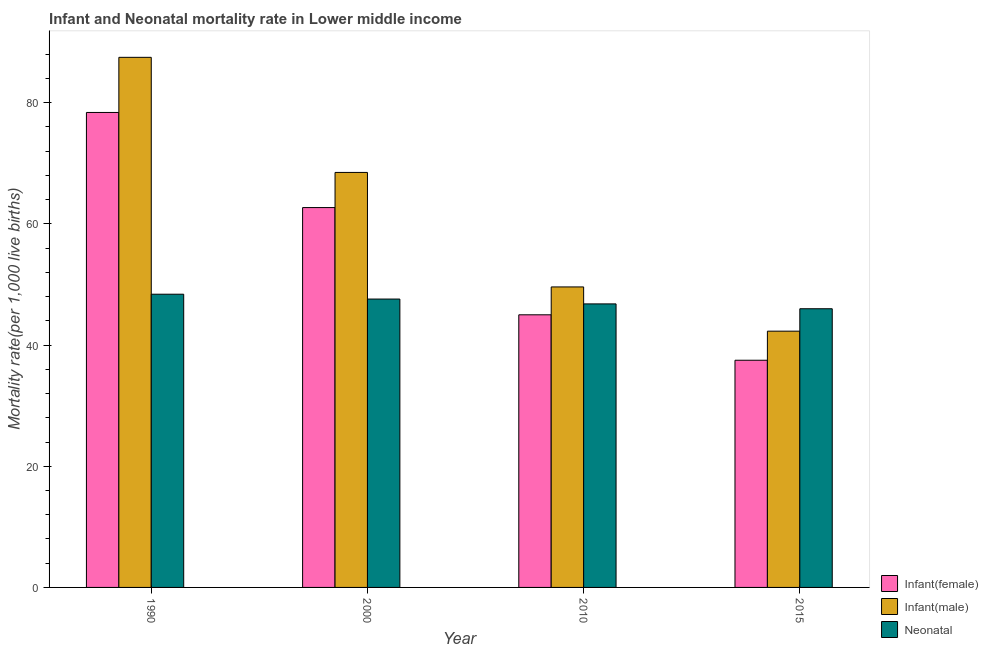How many groups of bars are there?
Offer a very short reply. 4. Are the number of bars on each tick of the X-axis equal?
Your answer should be very brief. Yes. How many bars are there on the 4th tick from the left?
Provide a succinct answer. 3. How many bars are there on the 4th tick from the right?
Make the answer very short. 3. In how many cases, is the number of bars for a given year not equal to the number of legend labels?
Provide a short and direct response. 0. What is the infant mortality rate(female) in 2000?
Provide a short and direct response. 62.7. Across all years, what is the maximum infant mortality rate(female)?
Offer a very short reply. 78.4. Across all years, what is the minimum infant mortality rate(male)?
Ensure brevity in your answer.  42.3. In which year was the neonatal mortality rate maximum?
Offer a very short reply. 1990. In which year was the infant mortality rate(female) minimum?
Your response must be concise. 2015. What is the total neonatal mortality rate in the graph?
Keep it short and to the point. 188.8. What is the difference between the neonatal mortality rate in 1990 and that in 2000?
Give a very brief answer. 0.8. What is the difference between the neonatal mortality rate in 2015 and the infant mortality rate(female) in 1990?
Your answer should be compact. -2.4. What is the average infant mortality rate(female) per year?
Offer a terse response. 55.9. In the year 1990, what is the difference between the neonatal mortality rate and infant mortality rate(male)?
Make the answer very short. 0. What is the ratio of the neonatal mortality rate in 1990 to that in 2000?
Provide a succinct answer. 1.02. Is the infant mortality rate(female) in 2000 less than that in 2010?
Your answer should be compact. No. What is the difference between the highest and the second highest infant mortality rate(female)?
Offer a very short reply. 15.7. What is the difference between the highest and the lowest neonatal mortality rate?
Your response must be concise. 2.4. Is the sum of the neonatal mortality rate in 1990 and 2015 greater than the maximum infant mortality rate(female) across all years?
Provide a succinct answer. Yes. What does the 3rd bar from the left in 2000 represents?
Offer a terse response. Neonatal . What does the 2nd bar from the right in 1990 represents?
Your answer should be compact. Infant(male). Is it the case that in every year, the sum of the infant mortality rate(female) and infant mortality rate(male) is greater than the neonatal mortality rate?
Ensure brevity in your answer.  Yes. How many years are there in the graph?
Provide a succinct answer. 4. Are the values on the major ticks of Y-axis written in scientific E-notation?
Ensure brevity in your answer.  No. Where does the legend appear in the graph?
Make the answer very short. Bottom right. How many legend labels are there?
Offer a terse response. 3. What is the title of the graph?
Provide a short and direct response. Infant and Neonatal mortality rate in Lower middle income. Does "Oil sources" appear as one of the legend labels in the graph?
Provide a short and direct response. No. What is the label or title of the X-axis?
Offer a very short reply. Year. What is the label or title of the Y-axis?
Your answer should be compact. Mortality rate(per 1,0 live births). What is the Mortality rate(per 1,000 live births) in Infant(female) in 1990?
Your answer should be very brief. 78.4. What is the Mortality rate(per 1,000 live births) in Infant(male) in 1990?
Ensure brevity in your answer.  87.5. What is the Mortality rate(per 1,000 live births) in Neonatal  in 1990?
Keep it short and to the point. 48.4. What is the Mortality rate(per 1,000 live births) of Infant(female) in 2000?
Your answer should be very brief. 62.7. What is the Mortality rate(per 1,000 live births) of Infant(male) in 2000?
Offer a terse response. 68.5. What is the Mortality rate(per 1,000 live births) in Neonatal  in 2000?
Provide a succinct answer. 47.6. What is the Mortality rate(per 1,000 live births) of Infant(male) in 2010?
Your answer should be compact. 49.6. What is the Mortality rate(per 1,000 live births) of Neonatal  in 2010?
Your answer should be compact. 46.8. What is the Mortality rate(per 1,000 live births) in Infant(female) in 2015?
Ensure brevity in your answer.  37.5. What is the Mortality rate(per 1,000 live births) in Infant(male) in 2015?
Offer a very short reply. 42.3. Across all years, what is the maximum Mortality rate(per 1,000 live births) in Infant(female)?
Keep it short and to the point. 78.4. Across all years, what is the maximum Mortality rate(per 1,000 live births) in Infant(male)?
Keep it short and to the point. 87.5. Across all years, what is the maximum Mortality rate(per 1,000 live births) in Neonatal ?
Offer a very short reply. 48.4. Across all years, what is the minimum Mortality rate(per 1,000 live births) of Infant(female)?
Ensure brevity in your answer.  37.5. Across all years, what is the minimum Mortality rate(per 1,000 live births) of Infant(male)?
Provide a succinct answer. 42.3. What is the total Mortality rate(per 1,000 live births) in Infant(female) in the graph?
Offer a terse response. 223.6. What is the total Mortality rate(per 1,000 live births) of Infant(male) in the graph?
Make the answer very short. 247.9. What is the total Mortality rate(per 1,000 live births) of Neonatal  in the graph?
Provide a succinct answer. 188.8. What is the difference between the Mortality rate(per 1,000 live births) in Infant(female) in 1990 and that in 2000?
Make the answer very short. 15.7. What is the difference between the Mortality rate(per 1,000 live births) in Infant(female) in 1990 and that in 2010?
Make the answer very short. 33.4. What is the difference between the Mortality rate(per 1,000 live births) in Infant(male) in 1990 and that in 2010?
Provide a succinct answer. 37.9. What is the difference between the Mortality rate(per 1,000 live births) in Neonatal  in 1990 and that in 2010?
Ensure brevity in your answer.  1.6. What is the difference between the Mortality rate(per 1,000 live births) in Infant(female) in 1990 and that in 2015?
Your answer should be compact. 40.9. What is the difference between the Mortality rate(per 1,000 live births) of Infant(male) in 1990 and that in 2015?
Make the answer very short. 45.2. What is the difference between the Mortality rate(per 1,000 live births) of Infant(female) in 2000 and that in 2010?
Provide a succinct answer. 17.7. What is the difference between the Mortality rate(per 1,000 live births) of Infant(male) in 2000 and that in 2010?
Ensure brevity in your answer.  18.9. What is the difference between the Mortality rate(per 1,000 live births) in Infant(female) in 2000 and that in 2015?
Ensure brevity in your answer.  25.2. What is the difference between the Mortality rate(per 1,000 live births) of Infant(male) in 2000 and that in 2015?
Your response must be concise. 26.2. What is the difference between the Mortality rate(per 1,000 live births) in Infant(female) in 2010 and that in 2015?
Ensure brevity in your answer.  7.5. What is the difference between the Mortality rate(per 1,000 live births) in Infant(female) in 1990 and the Mortality rate(per 1,000 live births) in Infant(male) in 2000?
Offer a very short reply. 9.9. What is the difference between the Mortality rate(per 1,000 live births) in Infant(female) in 1990 and the Mortality rate(per 1,000 live births) in Neonatal  in 2000?
Provide a short and direct response. 30.8. What is the difference between the Mortality rate(per 1,000 live births) in Infant(male) in 1990 and the Mortality rate(per 1,000 live births) in Neonatal  in 2000?
Your response must be concise. 39.9. What is the difference between the Mortality rate(per 1,000 live births) of Infant(female) in 1990 and the Mortality rate(per 1,000 live births) of Infant(male) in 2010?
Give a very brief answer. 28.8. What is the difference between the Mortality rate(per 1,000 live births) of Infant(female) in 1990 and the Mortality rate(per 1,000 live births) of Neonatal  in 2010?
Make the answer very short. 31.6. What is the difference between the Mortality rate(per 1,000 live births) of Infant(male) in 1990 and the Mortality rate(per 1,000 live births) of Neonatal  in 2010?
Offer a very short reply. 40.7. What is the difference between the Mortality rate(per 1,000 live births) in Infant(female) in 1990 and the Mortality rate(per 1,000 live births) in Infant(male) in 2015?
Provide a succinct answer. 36.1. What is the difference between the Mortality rate(per 1,000 live births) in Infant(female) in 1990 and the Mortality rate(per 1,000 live births) in Neonatal  in 2015?
Offer a terse response. 32.4. What is the difference between the Mortality rate(per 1,000 live births) in Infant(male) in 1990 and the Mortality rate(per 1,000 live births) in Neonatal  in 2015?
Offer a very short reply. 41.5. What is the difference between the Mortality rate(per 1,000 live births) of Infant(male) in 2000 and the Mortality rate(per 1,000 live births) of Neonatal  in 2010?
Provide a short and direct response. 21.7. What is the difference between the Mortality rate(per 1,000 live births) in Infant(female) in 2000 and the Mortality rate(per 1,000 live births) in Infant(male) in 2015?
Ensure brevity in your answer.  20.4. What is the difference between the Mortality rate(per 1,000 live births) of Infant(female) in 2000 and the Mortality rate(per 1,000 live births) of Neonatal  in 2015?
Offer a terse response. 16.7. What is the difference between the Mortality rate(per 1,000 live births) of Infant(female) in 2010 and the Mortality rate(per 1,000 live births) of Infant(male) in 2015?
Offer a terse response. 2.7. What is the difference between the Mortality rate(per 1,000 live births) of Infant(female) in 2010 and the Mortality rate(per 1,000 live births) of Neonatal  in 2015?
Ensure brevity in your answer.  -1. What is the difference between the Mortality rate(per 1,000 live births) in Infant(male) in 2010 and the Mortality rate(per 1,000 live births) in Neonatal  in 2015?
Ensure brevity in your answer.  3.6. What is the average Mortality rate(per 1,000 live births) in Infant(female) per year?
Your response must be concise. 55.9. What is the average Mortality rate(per 1,000 live births) of Infant(male) per year?
Ensure brevity in your answer.  61.98. What is the average Mortality rate(per 1,000 live births) in Neonatal  per year?
Offer a very short reply. 47.2. In the year 1990, what is the difference between the Mortality rate(per 1,000 live births) in Infant(male) and Mortality rate(per 1,000 live births) in Neonatal ?
Your response must be concise. 39.1. In the year 2000, what is the difference between the Mortality rate(per 1,000 live births) in Infant(female) and Mortality rate(per 1,000 live births) in Infant(male)?
Give a very brief answer. -5.8. In the year 2000, what is the difference between the Mortality rate(per 1,000 live births) in Infant(female) and Mortality rate(per 1,000 live births) in Neonatal ?
Make the answer very short. 15.1. In the year 2000, what is the difference between the Mortality rate(per 1,000 live births) in Infant(male) and Mortality rate(per 1,000 live births) in Neonatal ?
Your answer should be compact. 20.9. In the year 2010, what is the difference between the Mortality rate(per 1,000 live births) of Infant(female) and Mortality rate(per 1,000 live births) of Infant(male)?
Provide a succinct answer. -4.6. In the year 2010, what is the difference between the Mortality rate(per 1,000 live births) of Infant(female) and Mortality rate(per 1,000 live births) of Neonatal ?
Offer a terse response. -1.8. In the year 2010, what is the difference between the Mortality rate(per 1,000 live births) in Infant(male) and Mortality rate(per 1,000 live births) in Neonatal ?
Offer a very short reply. 2.8. What is the ratio of the Mortality rate(per 1,000 live births) in Infant(female) in 1990 to that in 2000?
Your response must be concise. 1.25. What is the ratio of the Mortality rate(per 1,000 live births) of Infant(male) in 1990 to that in 2000?
Your answer should be compact. 1.28. What is the ratio of the Mortality rate(per 1,000 live births) in Neonatal  in 1990 to that in 2000?
Your answer should be compact. 1.02. What is the ratio of the Mortality rate(per 1,000 live births) in Infant(female) in 1990 to that in 2010?
Your answer should be compact. 1.74. What is the ratio of the Mortality rate(per 1,000 live births) in Infant(male) in 1990 to that in 2010?
Give a very brief answer. 1.76. What is the ratio of the Mortality rate(per 1,000 live births) of Neonatal  in 1990 to that in 2010?
Offer a terse response. 1.03. What is the ratio of the Mortality rate(per 1,000 live births) of Infant(female) in 1990 to that in 2015?
Your response must be concise. 2.09. What is the ratio of the Mortality rate(per 1,000 live births) in Infant(male) in 1990 to that in 2015?
Offer a very short reply. 2.07. What is the ratio of the Mortality rate(per 1,000 live births) in Neonatal  in 1990 to that in 2015?
Your response must be concise. 1.05. What is the ratio of the Mortality rate(per 1,000 live births) in Infant(female) in 2000 to that in 2010?
Your answer should be compact. 1.39. What is the ratio of the Mortality rate(per 1,000 live births) of Infant(male) in 2000 to that in 2010?
Your answer should be compact. 1.38. What is the ratio of the Mortality rate(per 1,000 live births) of Neonatal  in 2000 to that in 2010?
Offer a terse response. 1.02. What is the ratio of the Mortality rate(per 1,000 live births) in Infant(female) in 2000 to that in 2015?
Ensure brevity in your answer.  1.67. What is the ratio of the Mortality rate(per 1,000 live births) of Infant(male) in 2000 to that in 2015?
Provide a short and direct response. 1.62. What is the ratio of the Mortality rate(per 1,000 live births) of Neonatal  in 2000 to that in 2015?
Make the answer very short. 1.03. What is the ratio of the Mortality rate(per 1,000 live births) of Infant(male) in 2010 to that in 2015?
Keep it short and to the point. 1.17. What is the ratio of the Mortality rate(per 1,000 live births) of Neonatal  in 2010 to that in 2015?
Make the answer very short. 1.02. What is the difference between the highest and the second highest Mortality rate(per 1,000 live births) in Infant(male)?
Your answer should be compact. 19. What is the difference between the highest and the lowest Mortality rate(per 1,000 live births) in Infant(female)?
Keep it short and to the point. 40.9. What is the difference between the highest and the lowest Mortality rate(per 1,000 live births) in Infant(male)?
Your answer should be very brief. 45.2. What is the difference between the highest and the lowest Mortality rate(per 1,000 live births) of Neonatal ?
Make the answer very short. 2.4. 